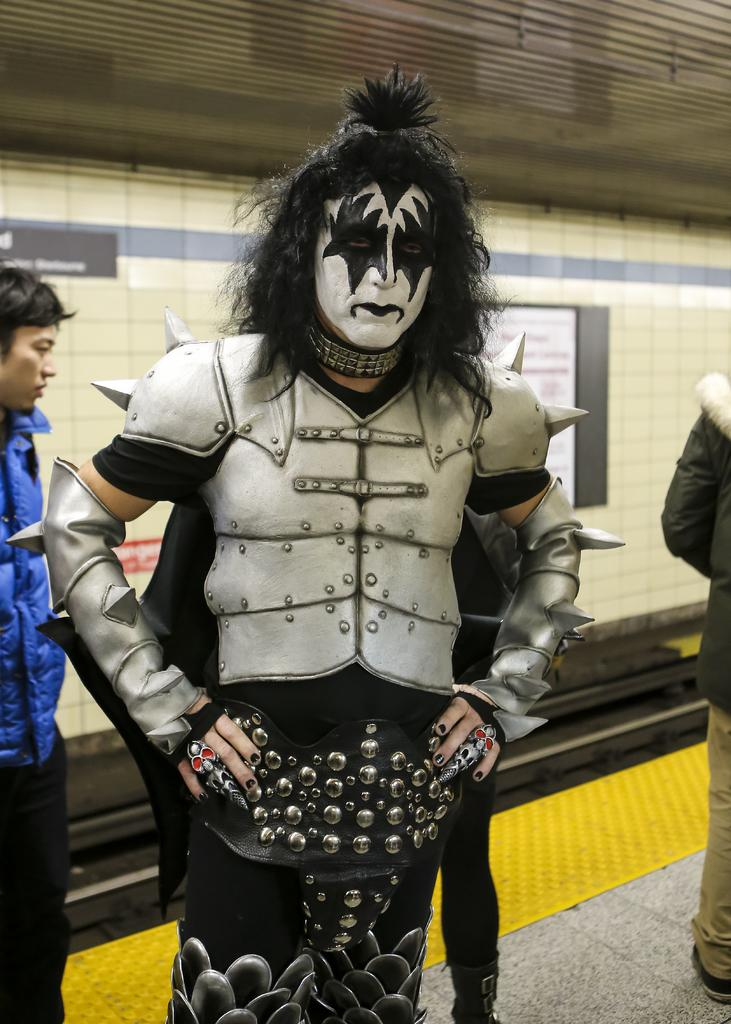How many people are in the image? There are people standing in the image. Can you describe the attire of one of the individuals? One of the people is wearing a costume. What can be seen in the background of the image? There are boards visible in the background of the image. What nation was discovered by the person wearing the costume in the image? There is no indication in the image that the person wearing the costume discovered any nation. 